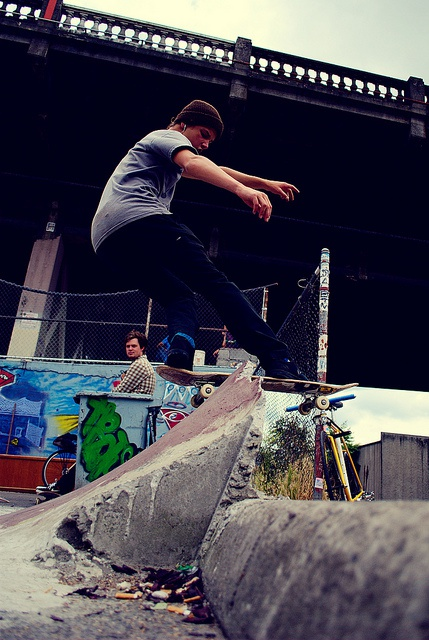Describe the objects in this image and their specific colors. I can see people in navy, black, darkgray, gray, and maroon tones, skateboard in navy, black, gray, maroon, and tan tones, bicycle in navy, black, beige, and gray tones, people in navy, black, brown, gray, and darkgray tones, and bicycle in navy, black, maroon, and gray tones in this image. 